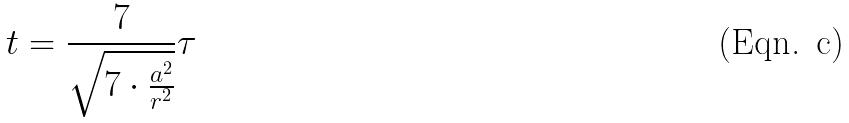<formula> <loc_0><loc_0><loc_500><loc_500>t = \frac { 7 } { \sqrt { 7 \cdot \frac { a ^ { 2 } } { r ^ { 2 } } } } \tau</formula> 